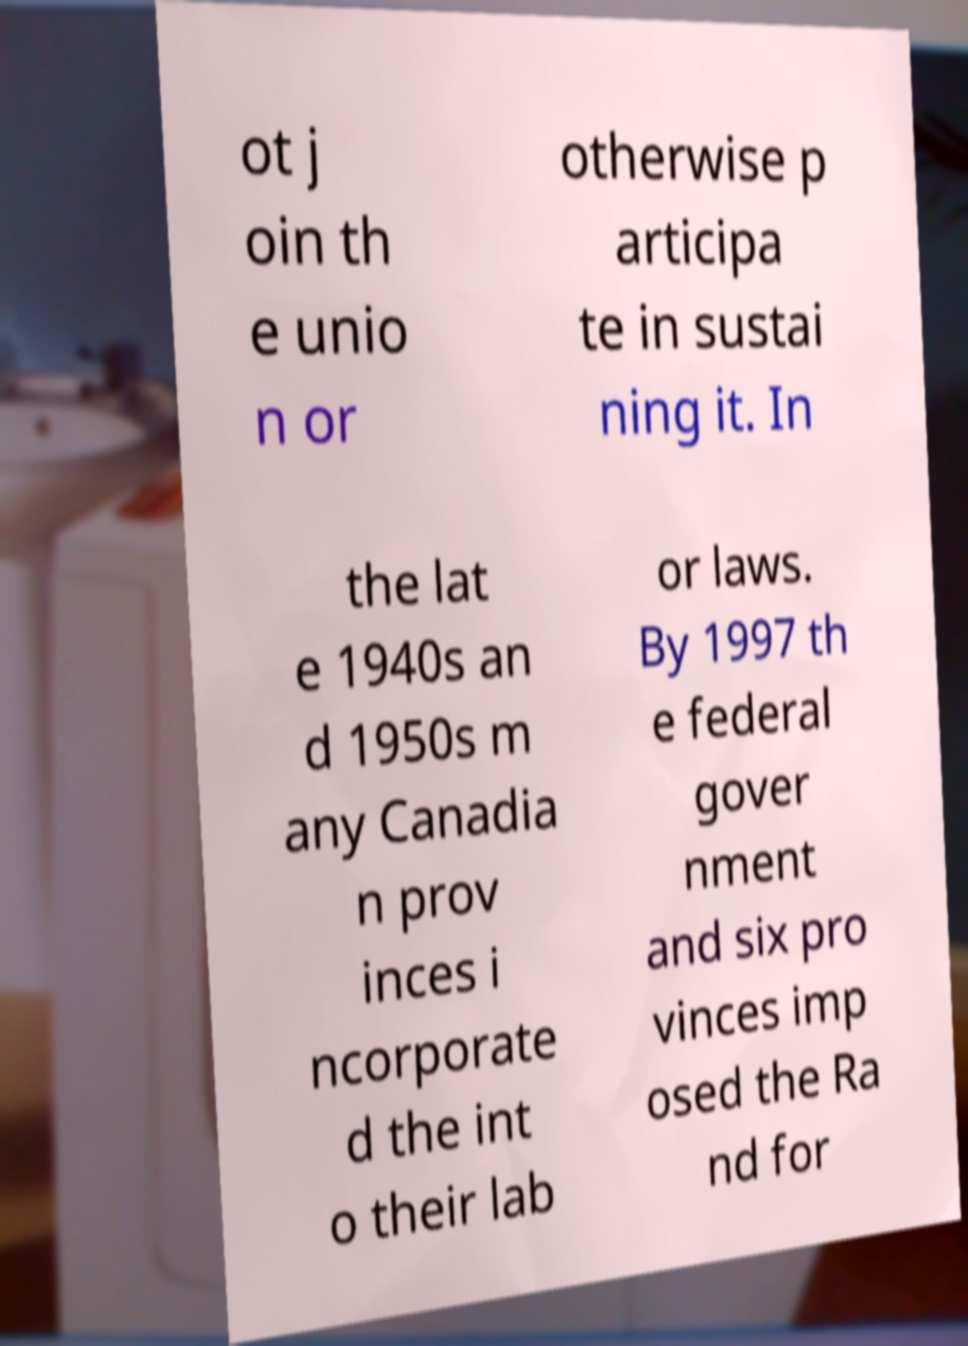Can you read and provide the text displayed in the image?This photo seems to have some interesting text. Can you extract and type it out for me? ot j oin th e unio n or otherwise p articipa te in sustai ning it. In the lat e 1940s an d 1950s m any Canadia n prov inces i ncorporate d the int o their lab or laws. By 1997 th e federal gover nment and six pro vinces imp osed the Ra nd for 